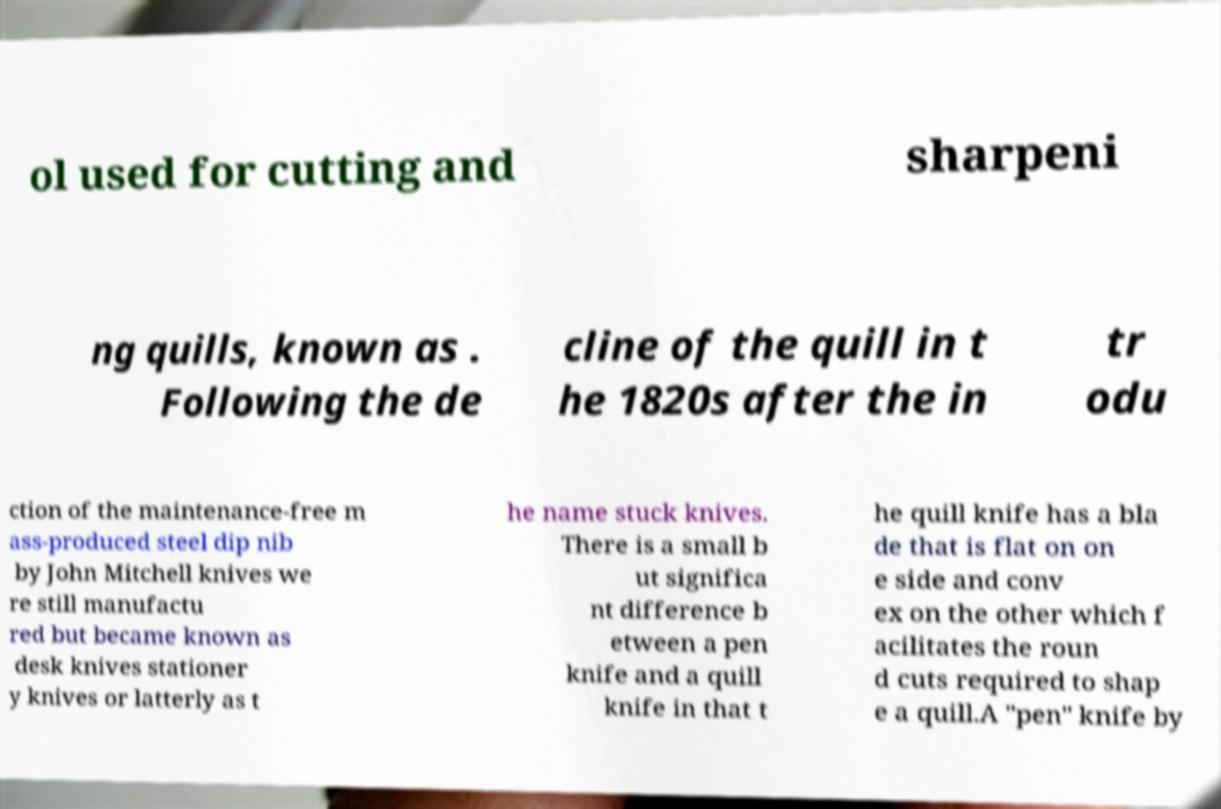Can you read and provide the text displayed in the image?This photo seems to have some interesting text. Can you extract and type it out for me? ol used for cutting and sharpeni ng quills, known as . Following the de cline of the quill in t he 1820s after the in tr odu ction of the maintenance-free m ass-produced steel dip nib by John Mitchell knives we re still manufactu red but became known as desk knives stationer y knives or latterly as t he name stuck knives. There is a small b ut significa nt difference b etween a pen knife and a quill knife in that t he quill knife has a bla de that is flat on on e side and conv ex on the other which f acilitates the roun d cuts required to shap e a quill.A "pen" knife by 